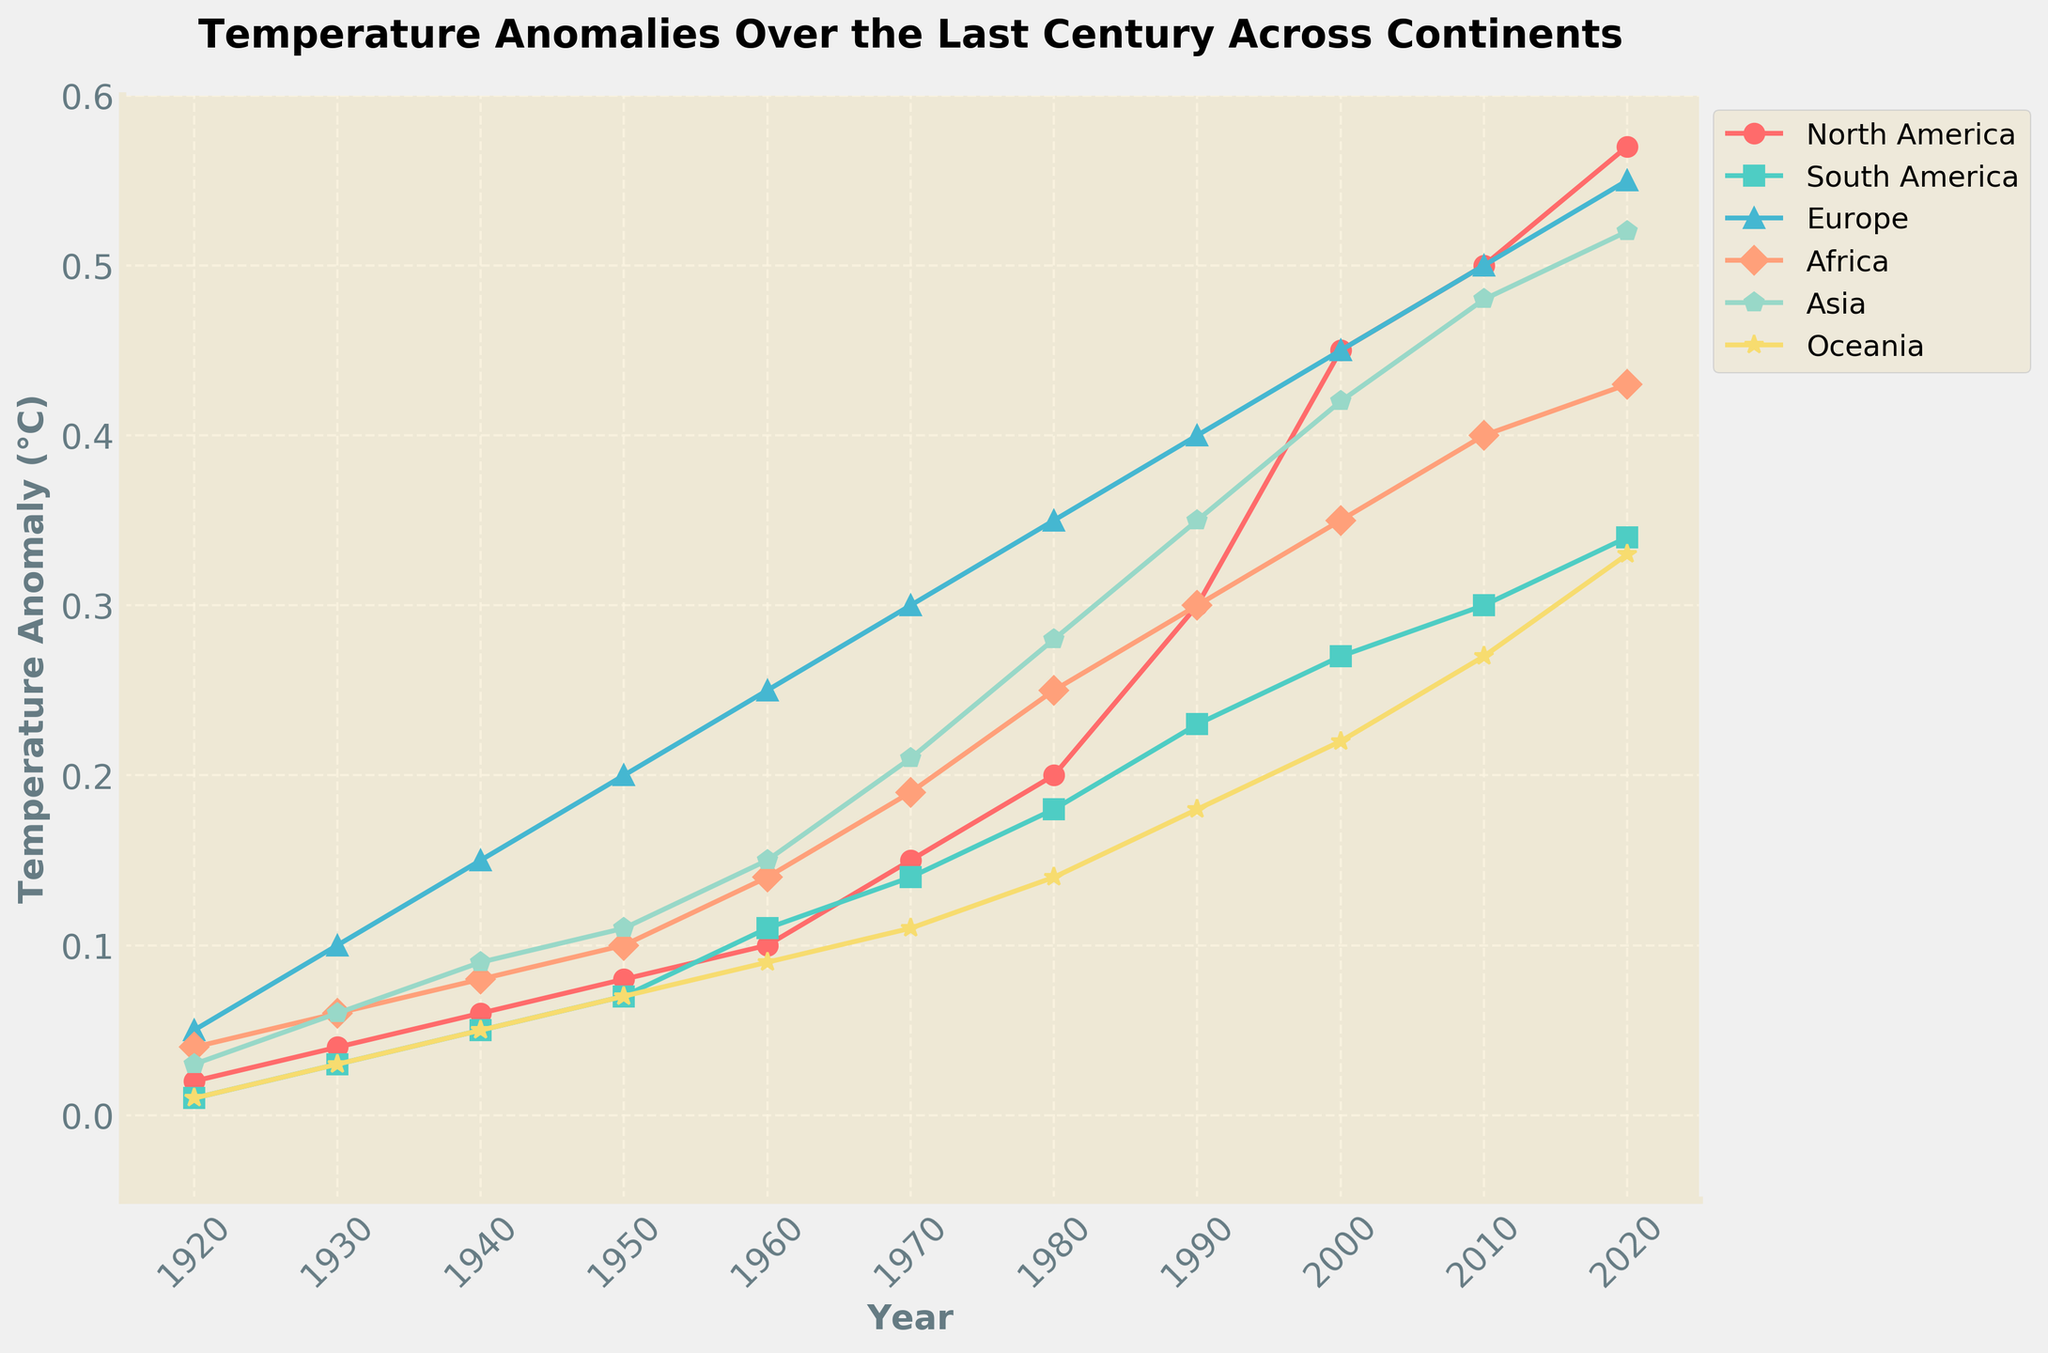What is the title of the figure? The title is displayed at the top of the graph. It summarizes the main idea, which in this case, is about temperature anomalies over a century across different continents.
Answer: Temperature Anomalies Over the Last Century Across Continents Which continent shows the highest temperature anomaly in 2020? By examining the values at the end of the time series for each continent in 2020, we can see that Asia has the highest temperature anomaly.
Answer: Asia How has the temperature anomaly in Europe changed from 1920 to 2020? Look at the starting (1920) and ending (2020) points of the Europe line. Subtract the 1920 value (0.05) from the 2020 value (0.55).
Answer: 0.5 Which two continents had the smallest temperature anomaly in 1940? Compare the data points for all continents for the year 1940. South America and Oceania have the smallest anomalies, both at 0.05.
Answer: South America and Oceania What is the average temperature anomaly in North America for the years 1920, 1930, and 1940? Add the values for North America for these years (0.02, 0.04, 0.06) and divide by 3. So, (0.02 + 0.04 + 0.06)/3 = 0.04
Answer: 0.04 Which continent had the steepest increase in temperature anomaly between 1970 and 2000? Calculate the difference in anomalies for each continent between 1970 and 2000. North America had an increase from 0.15 to 0.45, which is the largest change of 0.30.
Answer: North America In what year does Asia's temperature anomaly reach 0.42, and which other continent achieves the same anomaly by that year? Look at Asia's value touching 0.42, which occurs in 2000. By 2000, only Europe has an anomaly of 0.45 close to 0.42.
Answer: 2000, Europe Compare the temperature anomaly trends of North America and Europe. Are the trends similar or different? Observe the progression of the lines for North America and Europe. Both show an increasing trend over the century. However, Europe's anomalies generally started higher and increased at a slightly more constant rate. The trends are similar but differ in scale.
Answer: Similar trends 